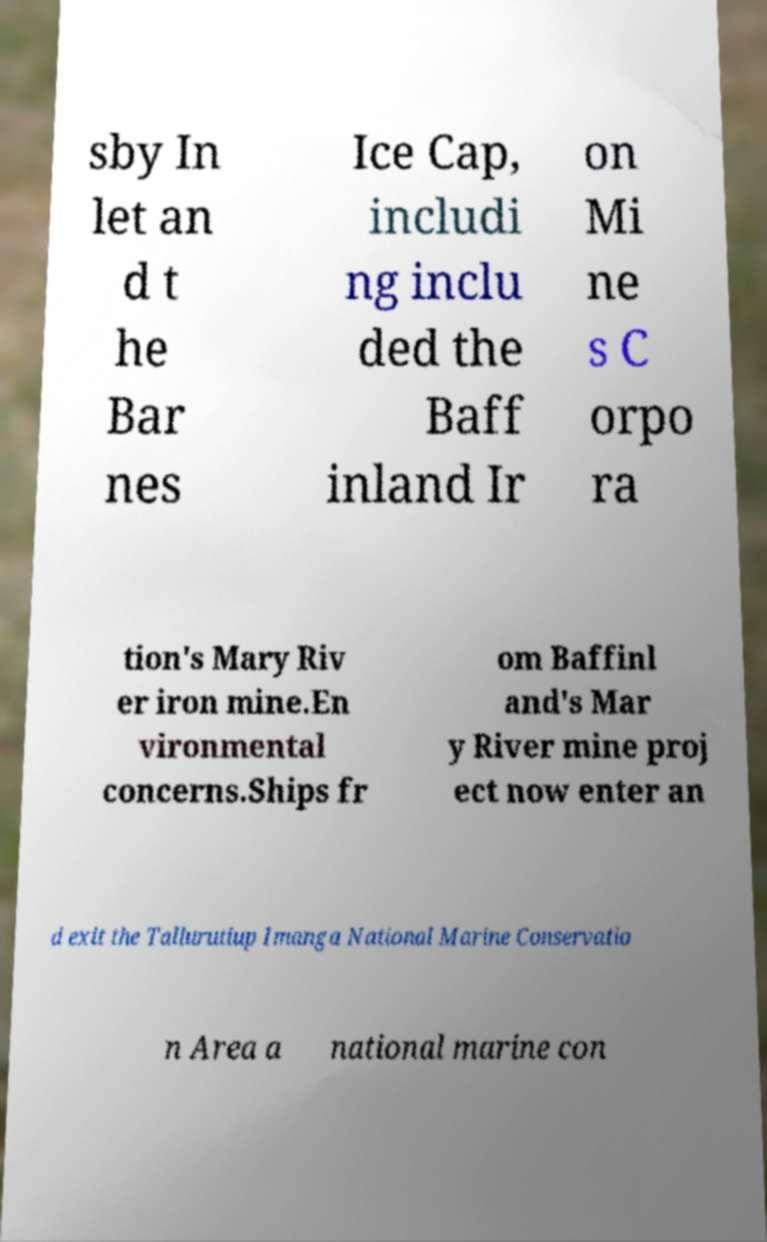For documentation purposes, I need the text within this image transcribed. Could you provide that? sby In let an d t he Bar nes Ice Cap, includi ng inclu ded the Baff inland Ir on Mi ne s C orpo ra tion's Mary Riv er iron mine.En vironmental concerns.Ships fr om Baffinl and's Mar y River mine proj ect now enter an d exit the Tallurutiup Imanga National Marine Conservatio n Area a national marine con 